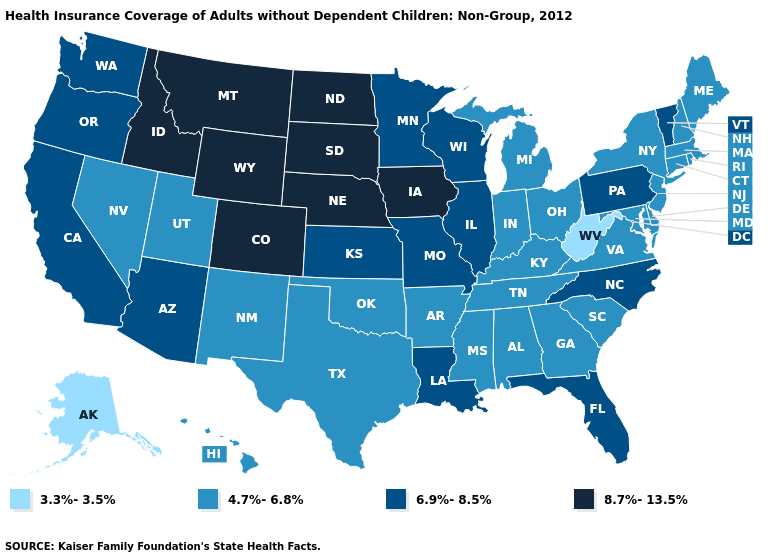What is the value of Louisiana?
Write a very short answer. 6.9%-8.5%. Name the states that have a value in the range 4.7%-6.8%?
Short answer required. Alabama, Arkansas, Connecticut, Delaware, Georgia, Hawaii, Indiana, Kentucky, Maine, Maryland, Massachusetts, Michigan, Mississippi, Nevada, New Hampshire, New Jersey, New Mexico, New York, Ohio, Oklahoma, Rhode Island, South Carolina, Tennessee, Texas, Utah, Virginia. What is the lowest value in the MidWest?
Answer briefly. 4.7%-6.8%. Which states have the lowest value in the USA?
Keep it brief. Alaska, West Virginia. Name the states that have a value in the range 3.3%-3.5%?
Be succinct. Alaska, West Virginia. What is the lowest value in the West?
Be succinct. 3.3%-3.5%. Name the states that have a value in the range 6.9%-8.5%?
Concise answer only. Arizona, California, Florida, Illinois, Kansas, Louisiana, Minnesota, Missouri, North Carolina, Oregon, Pennsylvania, Vermont, Washington, Wisconsin. Name the states that have a value in the range 3.3%-3.5%?
Quick response, please. Alaska, West Virginia. Name the states that have a value in the range 3.3%-3.5%?
Be succinct. Alaska, West Virginia. Name the states that have a value in the range 8.7%-13.5%?
Write a very short answer. Colorado, Idaho, Iowa, Montana, Nebraska, North Dakota, South Dakota, Wyoming. Does Nebraska have the highest value in the USA?
Give a very brief answer. Yes. Does North Dakota have the highest value in the USA?
Write a very short answer. Yes. What is the value of Oklahoma?
Quick response, please. 4.7%-6.8%. Does West Virginia have the lowest value in the South?
Give a very brief answer. Yes. What is the value of Nebraska?
Quick response, please. 8.7%-13.5%. 